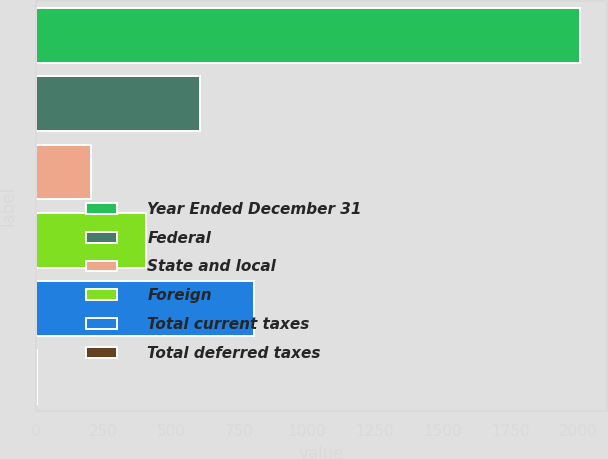Convert chart. <chart><loc_0><loc_0><loc_500><loc_500><bar_chart><fcel>Year Ended December 31<fcel>Federal<fcel>State and local<fcel>Foreign<fcel>Total current taxes<fcel>Total deferred taxes<nl><fcel>2007<fcel>605.04<fcel>204.48<fcel>404.76<fcel>805.32<fcel>4.2<nl></chart> 